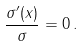Convert formula to latex. <formula><loc_0><loc_0><loc_500><loc_500>\frac { \sigma ^ { \prime } ( x ) } { \sigma } = 0 \, .</formula> 